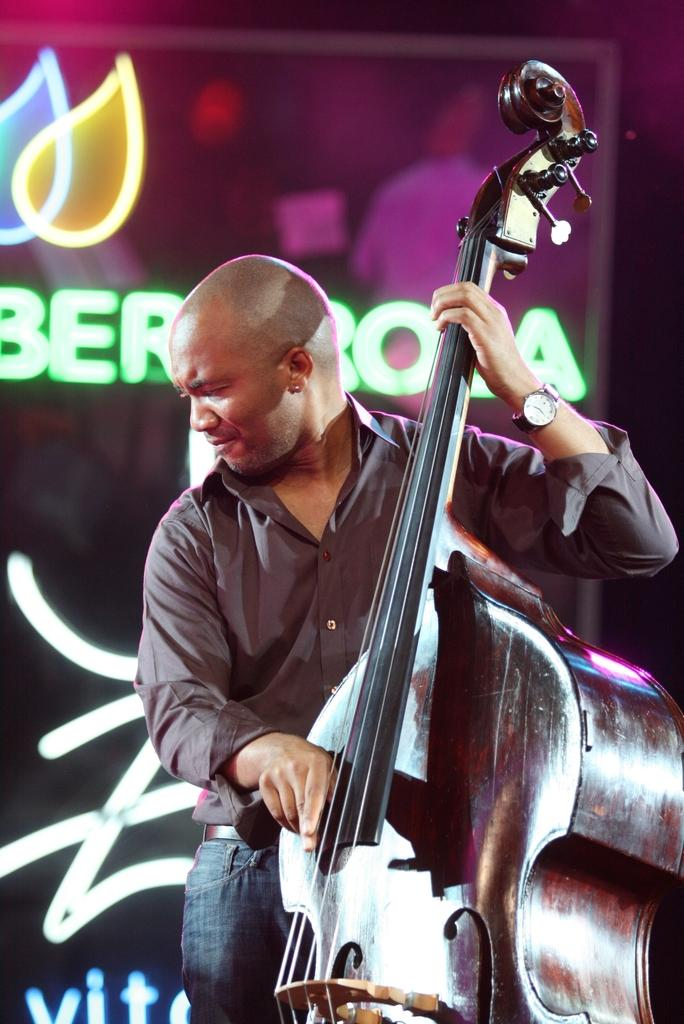What is the man in the image doing? The man is playing a cello, a musical instrument. Can you describe the background of the image? There is a colorful logo in the background of the image. What is written on the logo? There is some text or name written on the logo. What type of duck is sitting next to the man in the image? There is no duck present in the image; the man is playing a cello. Can you tell me the name of the man's sister in the image? There is no information about the man's sister in the image. 